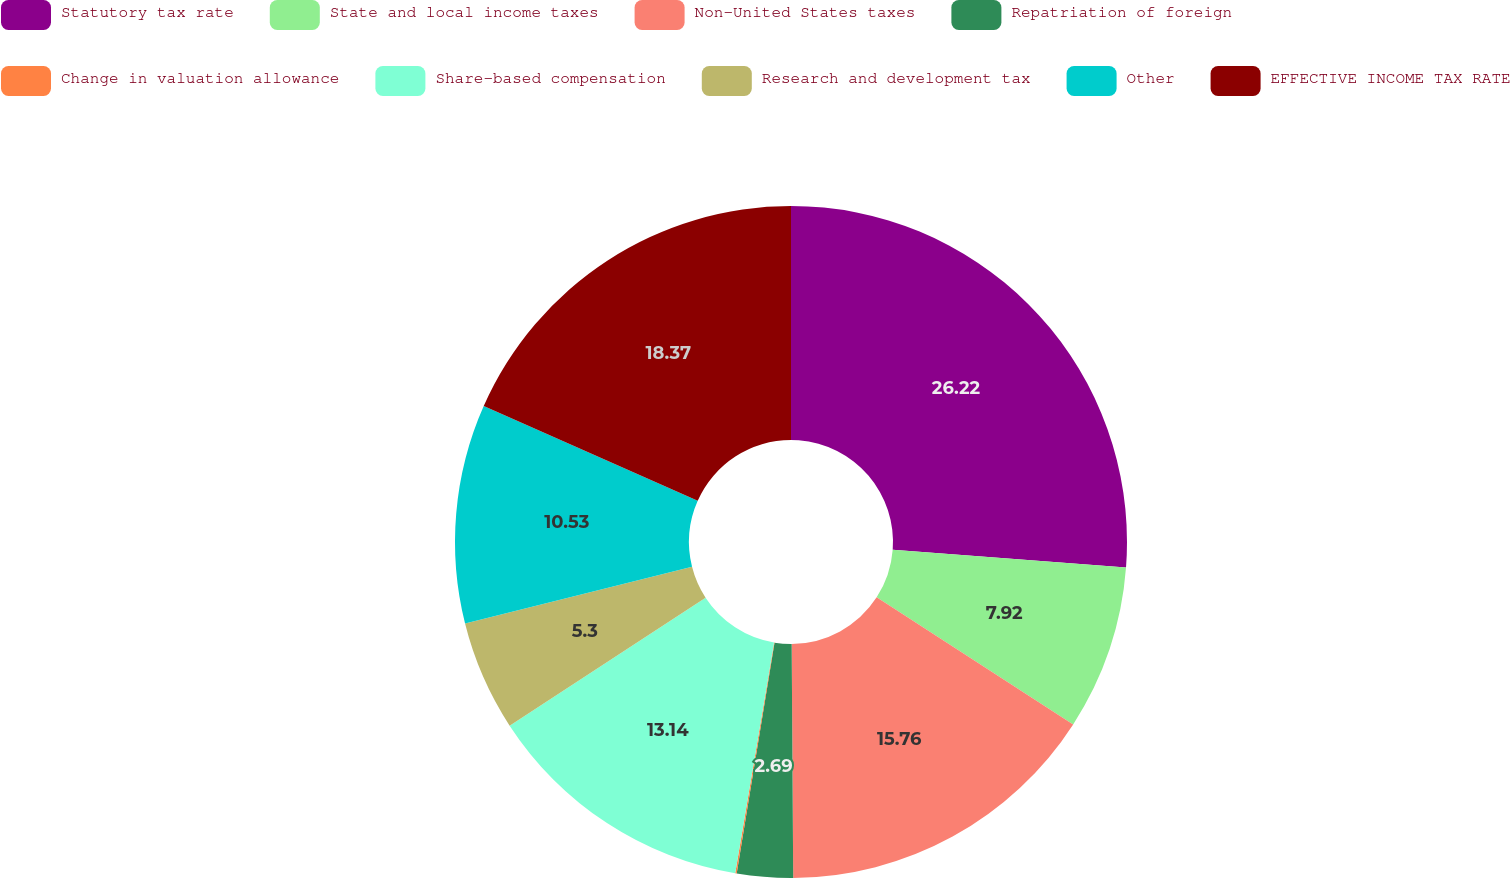Convert chart to OTSL. <chart><loc_0><loc_0><loc_500><loc_500><pie_chart><fcel>Statutory tax rate<fcel>State and local income taxes<fcel>Non-United States taxes<fcel>Repatriation of foreign<fcel>Change in valuation allowance<fcel>Share-based compensation<fcel>Research and development tax<fcel>Other<fcel>EFFECTIVE INCOME TAX RATE<nl><fcel>26.21%<fcel>7.92%<fcel>15.76%<fcel>2.69%<fcel>0.07%<fcel>13.14%<fcel>5.3%<fcel>10.53%<fcel>18.37%<nl></chart> 